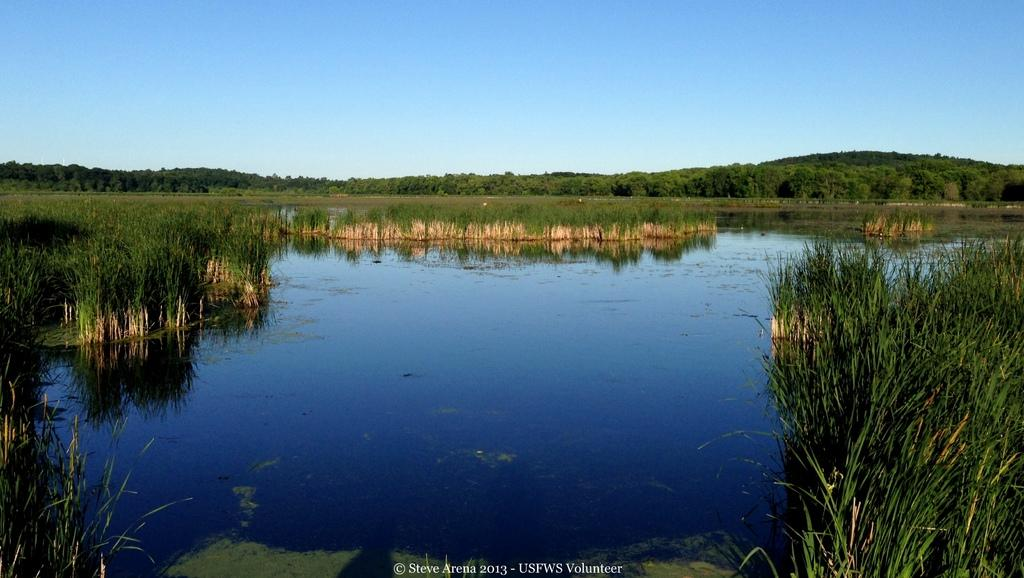What is the main feature in the image? There is a lake in the image. What type of vegetation surrounds the lake? The lake is surrounded by grass. What can be seen in the background of the image? The sky is visible in the background of the image. How many matches are visible in the image? There are no matches present in the image. What type of seed is growing near the lake in the image? There is no seed or indication of plant growth near the lake in the image. 